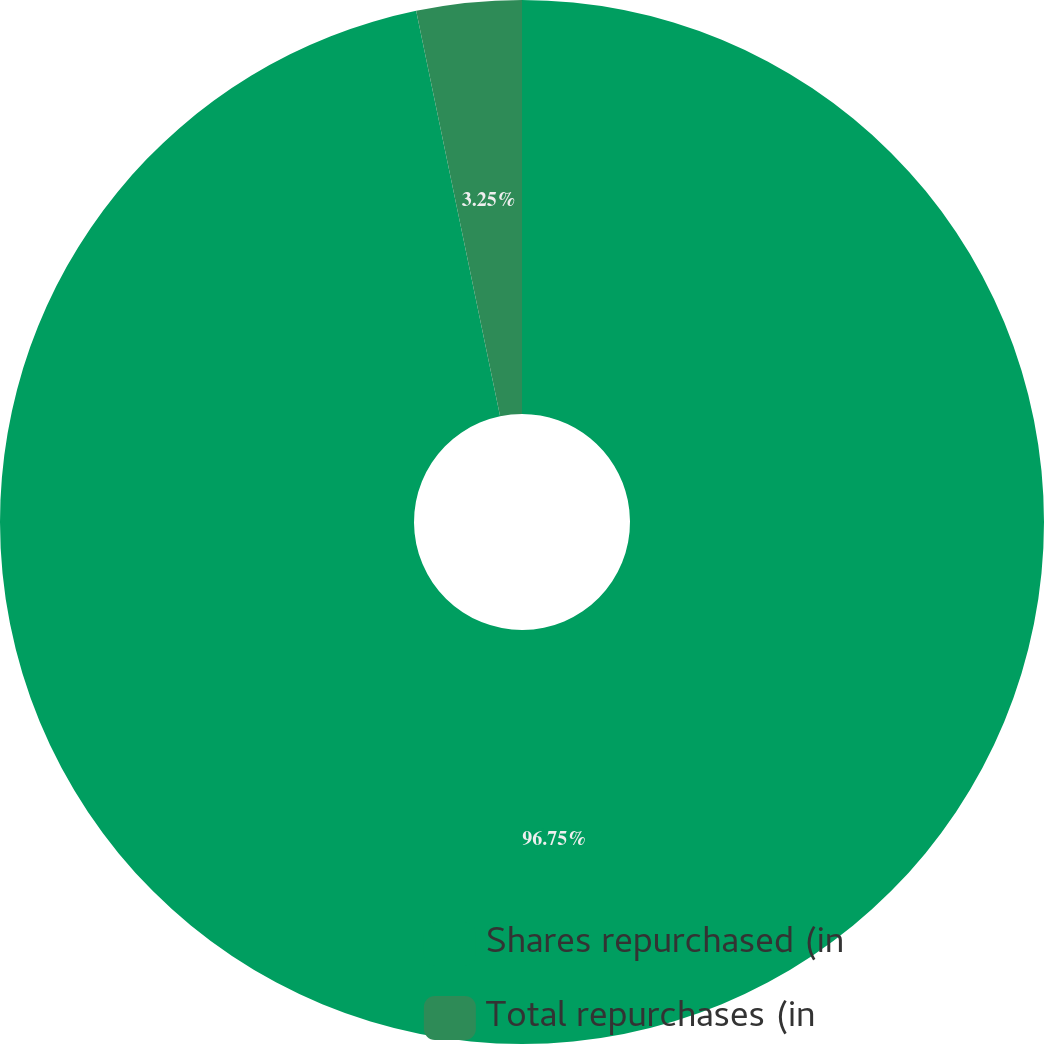Convert chart. <chart><loc_0><loc_0><loc_500><loc_500><pie_chart><fcel>Shares repurchased (in<fcel>Total repurchases (in<nl><fcel>96.75%<fcel>3.25%<nl></chart> 